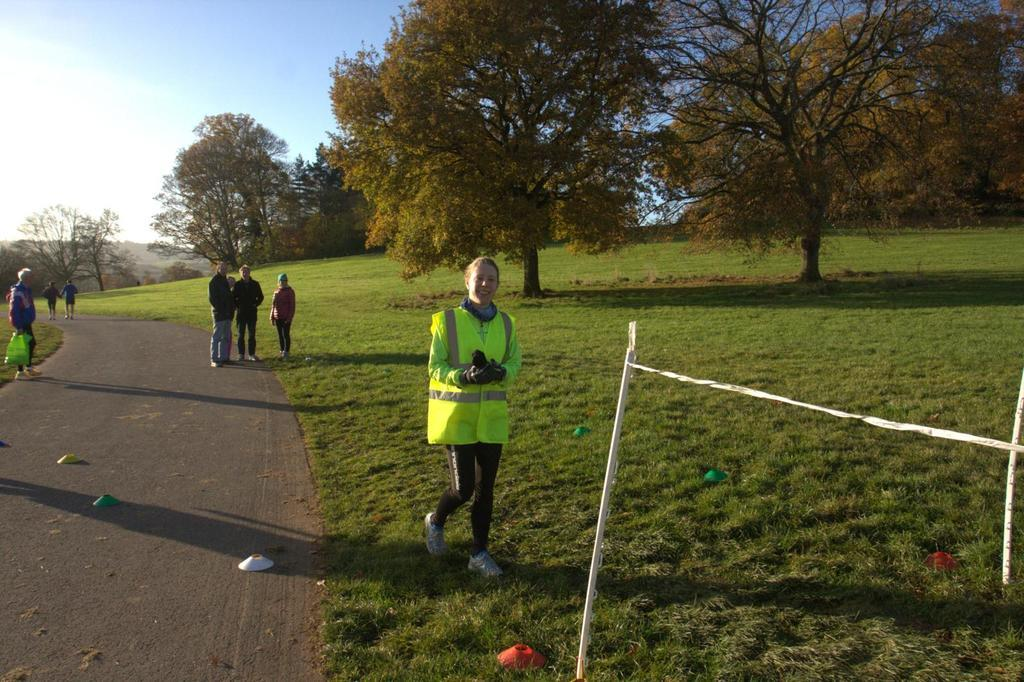How many people are in the image? There are people in the image, but the exact number is not specified. What are some of the people holding in the image? Some of the people are holding objects in the image. What type of vegetation can be seen in the image? There are trees and grass in the image. What other objects can be seen in the image besides the people and vegetation? There are other objects in the image, but their specific nature is not mentioned. What is visible in the background of the image? The sky is visible in the background of the image. What is the weight of the frog in the image? There is no frog present in the image, so its weight cannot be determined. 